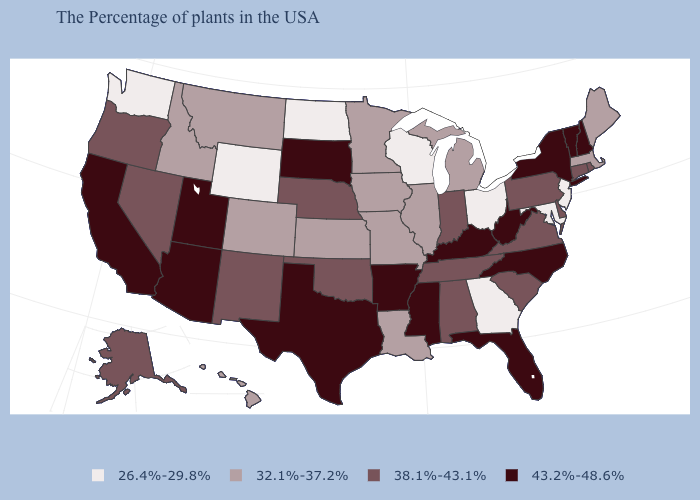Which states have the lowest value in the South?
Short answer required. Maryland, Georgia. Does the map have missing data?
Write a very short answer. No. How many symbols are there in the legend?
Give a very brief answer. 4. Name the states that have a value in the range 38.1%-43.1%?
Quick response, please. Rhode Island, Connecticut, Delaware, Pennsylvania, Virginia, South Carolina, Indiana, Alabama, Tennessee, Nebraska, Oklahoma, New Mexico, Nevada, Oregon, Alaska. Does the first symbol in the legend represent the smallest category?
Concise answer only. Yes. What is the value of Oregon?
Concise answer only. 38.1%-43.1%. Name the states that have a value in the range 43.2%-48.6%?
Write a very short answer. New Hampshire, Vermont, New York, North Carolina, West Virginia, Florida, Kentucky, Mississippi, Arkansas, Texas, South Dakota, Utah, Arizona, California. Name the states that have a value in the range 32.1%-37.2%?
Keep it brief. Maine, Massachusetts, Michigan, Illinois, Louisiana, Missouri, Minnesota, Iowa, Kansas, Colorado, Montana, Idaho, Hawaii. What is the highest value in states that border Massachusetts?
Short answer required. 43.2%-48.6%. What is the value of Rhode Island?
Quick response, please. 38.1%-43.1%. Among the states that border Arkansas , does Texas have the highest value?
Keep it brief. Yes. Name the states that have a value in the range 32.1%-37.2%?
Write a very short answer. Maine, Massachusetts, Michigan, Illinois, Louisiana, Missouri, Minnesota, Iowa, Kansas, Colorado, Montana, Idaho, Hawaii. Does Mississippi have the highest value in the South?
Answer briefly. Yes. What is the value of Mississippi?
Short answer required. 43.2%-48.6%. Is the legend a continuous bar?
Short answer required. No. 